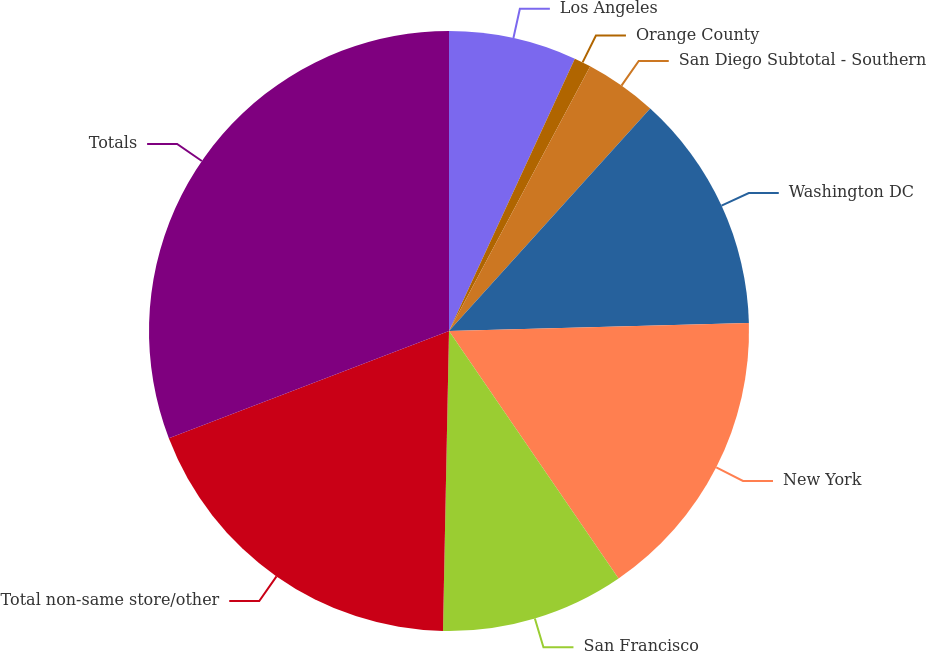Convert chart to OTSL. <chart><loc_0><loc_0><loc_500><loc_500><pie_chart><fcel>Los Angeles<fcel>Orange County<fcel>San Diego Subtotal - Southern<fcel>Washington DC<fcel>New York<fcel>San Francisco<fcel>Total non-same store/other<fcel>Totals<nl><fcel>6.89%<fcel>0.91%<fcel>3.9%<fcel>12.87%<fcel>15.87%<fcel>9.88%<fcel>18.86%<fcel>30.82%<nl></chart> 